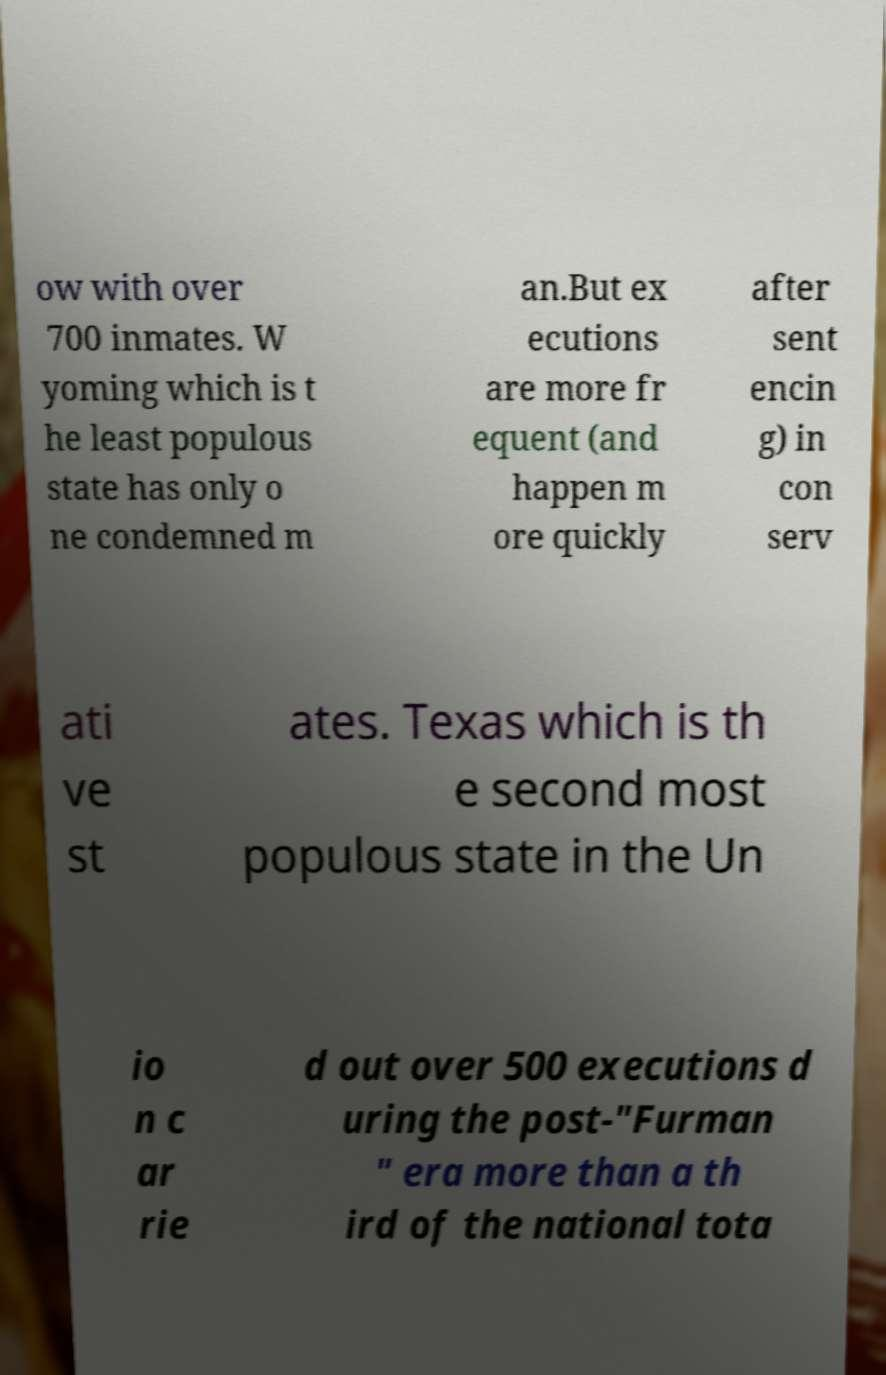Can you read and provide the text displayed in the image?This photo seems to have some interesting text. Can you extract and type it out for me? ow with over 700 inmates. W yoming which is t he least populous state has only o ne condemned m an.But ex ecutions are more fr equent (and happen m ore quickly after sent encin g) in con serv ati ve st ates. Texas which is th e second most populous state in the Un io n c ar rie d out over 500 executions d uring the post-"Furman " era more than a th ird of the national tota 